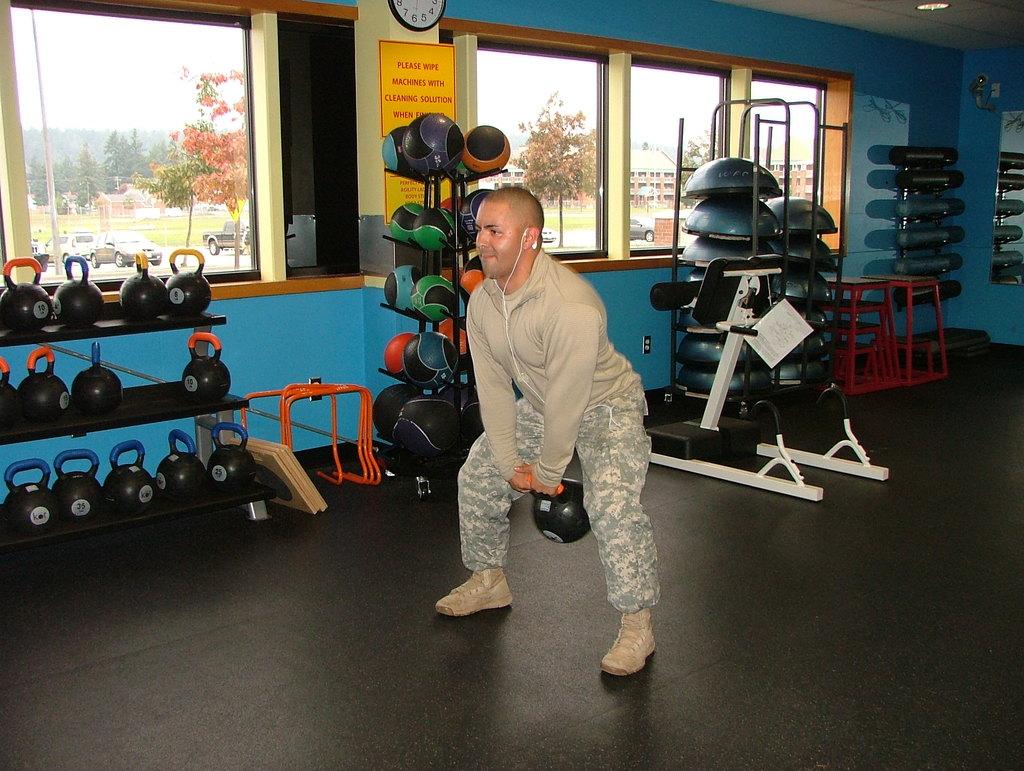What should you wipe the machines with?
Provide a short and direct response. Cleaning solution. What is the first word displayed on the yellow sign?
Offer a very short reply. Please. 